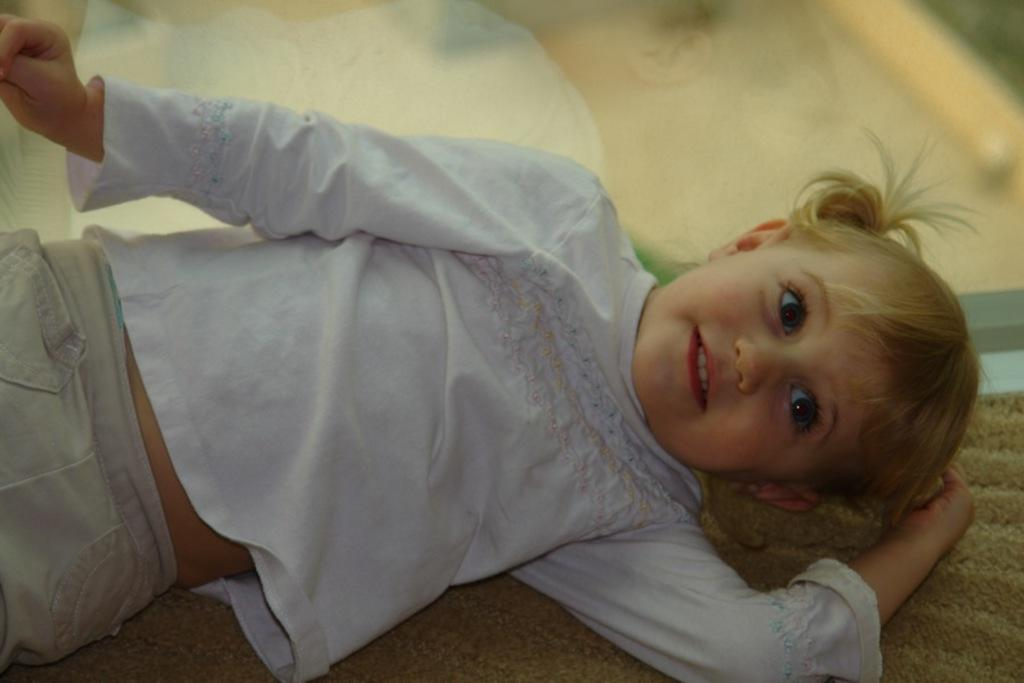What is the main subject of the image? There is a baby in the center of the image. What position is the baby in? The baby is lying down. What piece of furniture is visible at the bottom of the image? There is a couch at the bottom of the image. How would you describe the background of the image? The background of the image is blurred. What type of songs can be heard being sung by the deer in the image? There are no deer present in the image, and therefore no songs can be heard. 